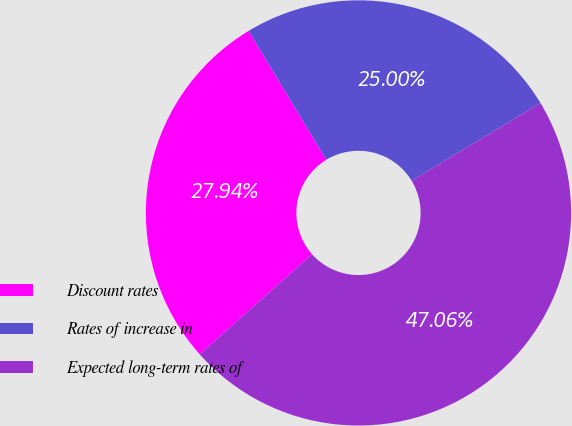<chart> <loc_0><loc_0><loc_500><loc_500><pie_chart><fcel>Discount rates<fcel>Rates of increase in<fcel>Expected long-term rates of<nl><fcel>27.94%<fcel>25.0%<fcel>47.06%<nl></chart> 